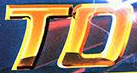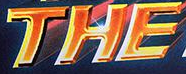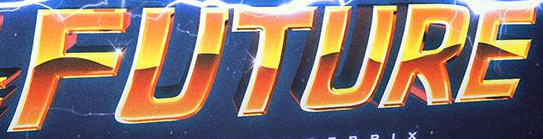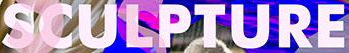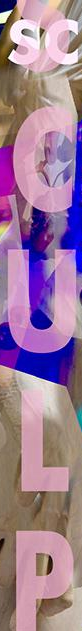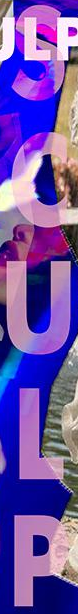What text is displayed in these images sequentially, separated by a semicolon? TO; THE; FUTURE; SCULPTURE; SCULP; SCULP 